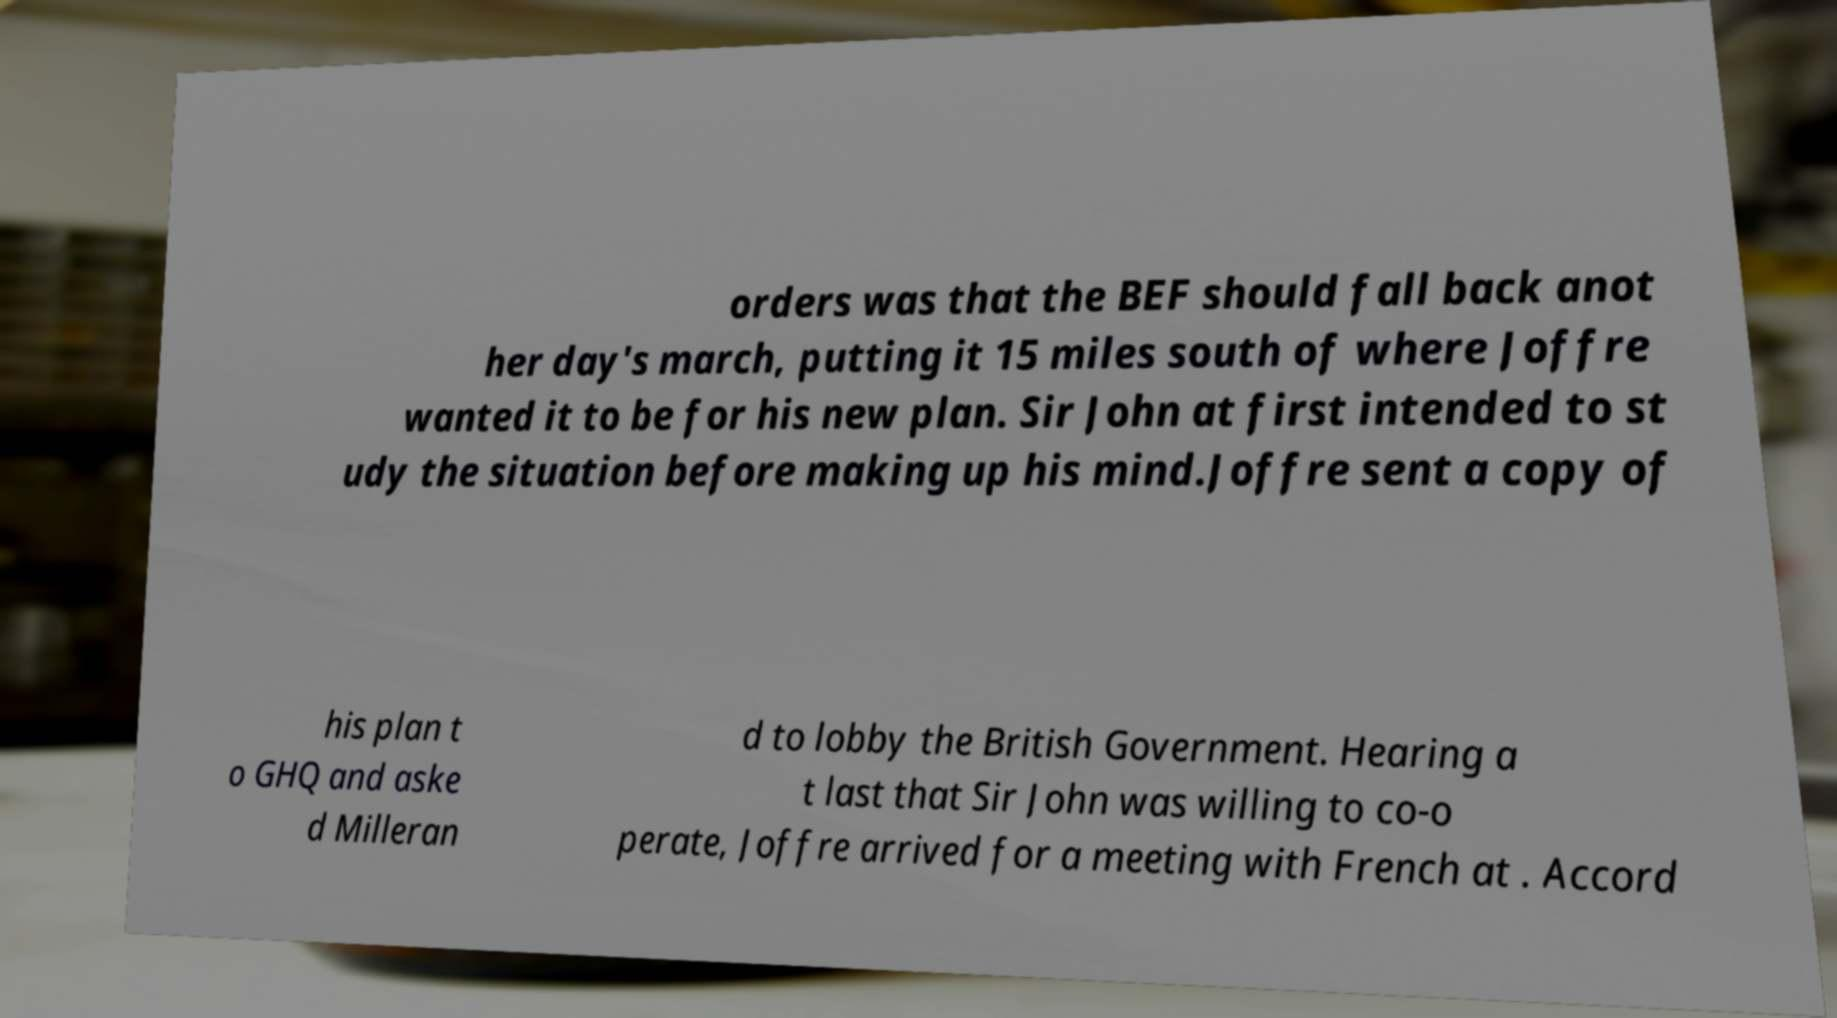There's text embedded in this image that I need extracted. Can you transcribe it verbatim? orders was that the BEF should fall back anot her day's march, putting it 15 miles south of where Joffre wanted it to be for his new plan. Sir John at first intended to st udy the situation before making up his mind.Joffre sent a copy of his plan t o GHQ and aske d Milleran d to lobby the British Government. Hearing a t last that Sir John was willing to co-o perate, Joffre arrived for a meeting with French at . Accord 